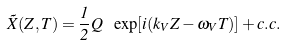Convert formula to latex. <formula><loc_0><loc_0><loc_500><loc_500>\tilde { X } ( Z , T ) = \frac { 1 } { 2 } Q \ \exp [ i ( k _ { V } Z - \omega _ { V } T ) ] + c . c .</formula> 